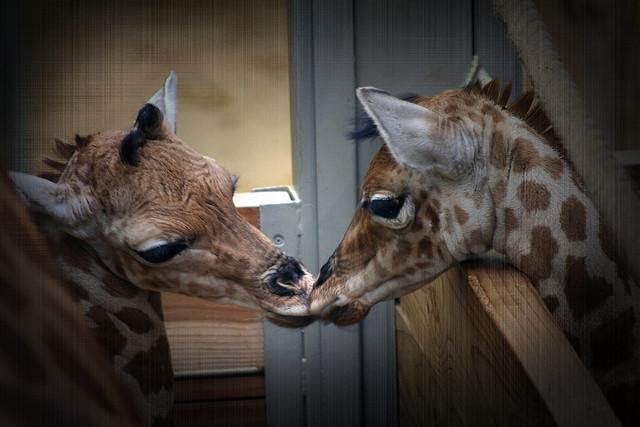Are these two baby giraffes?
Be succinct. Yes. Are these animals in the wild?
Quick response, please. No. Are these animals outdoors?
Concise answer only. No. 